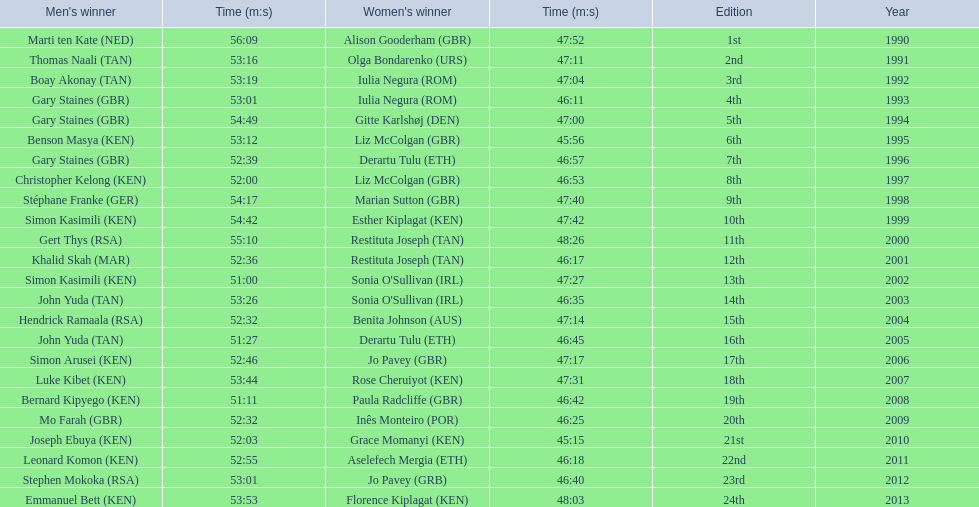Which runners are from kenya? (ken) Benson Masya (KEN), Christopher Kelong (KEN), Simon Kasimili (KEN), Simon Kasimili (KEN), Simon Arusei (KEN), Luke Kibet (KEN), Bernard Kipyego (KEN), Joseph Ebuya (KEN), Leonard Komon (KEN), Emmanuel Bett (KEN). Of these, which times are under 46 minutes? Benson Masya (KEN), Joseph Ebuya (KEN). Which of these runners had the faster time? Joseph Ebuya (KEN). 